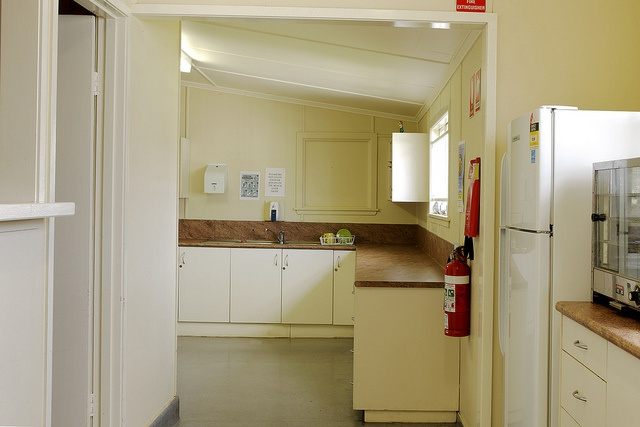Describe the objects in this image and their specific colors. I can see refrigerator in olive, darkgray, white, and tan tones, oven in olive, gray, darkgray, and black tones, sink in olive, gray, black, and maroon tones, and cup in olive tones in this image. 